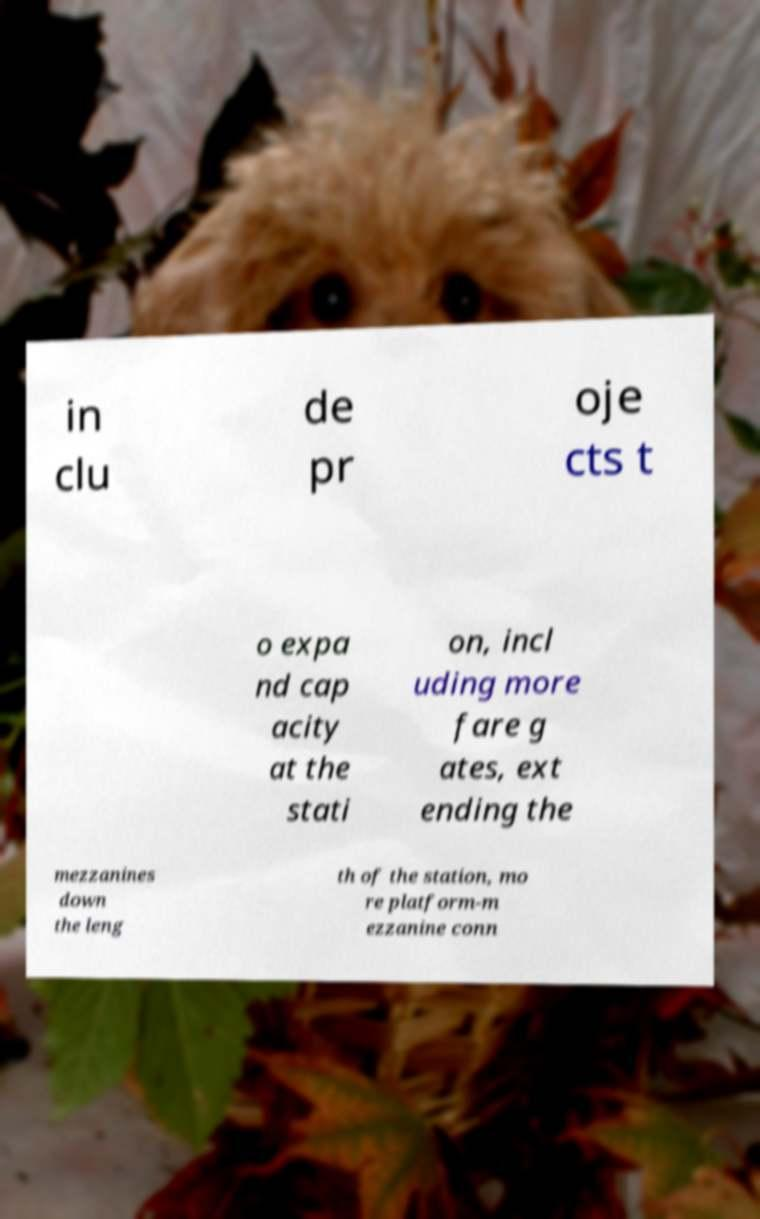There's text embedded in this image that I need extracted. Can you transcribe it verbatim? in clu de pr oje cts t o expa nd cap acity at the stati on, incl uding more fare g ates, ext ending the mezzanines down the leng th of the station, mo re platform-m ezzanine conn 